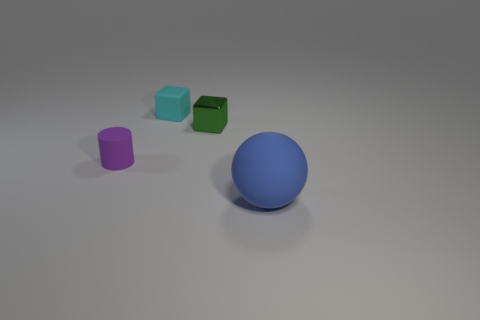There is a tiny thing behind the small green object; what number of green cubes are on the left side of it?
Provide a succinct answer. 0. Is the big blue rubber thing the same shape as the tiny cyan rubber thing?
Offer a very short reply. No. Is there anything else that is the same color as the rubber block?
Offer a terse response. No. There is a purple thing; is its shape the same as the rubber object that is right of the tiny cyan cube?
Your answer should be very brief. No. What color is the cube on the right side of the tiny object that is behind the tiny object right of the cyan rubber cube?
Your response must be concise. Green. Are there any other things that are made of the same material as the cyan thing?
Your answer should be very brief. Yes. There is a small rubber object that is behind the small purple cylinder; is it the same shape as the blue rubber thing?
Offer a very short reply. No. What is the blue sphere made of?
Provide a short and direct response. Rubber. What is the shape of the tiny matte thing that is on the right side of the tiny object to the left of the tiny block that is to the left of the small green metal cube?
Your response must be concise. Cube. How many other things are the same shape as the green thing?
Provide a succinct answer. 1. 